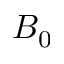<formula> <loc_0><loc_0><loc_500><loc_500>B _ { 0 }</formula> 